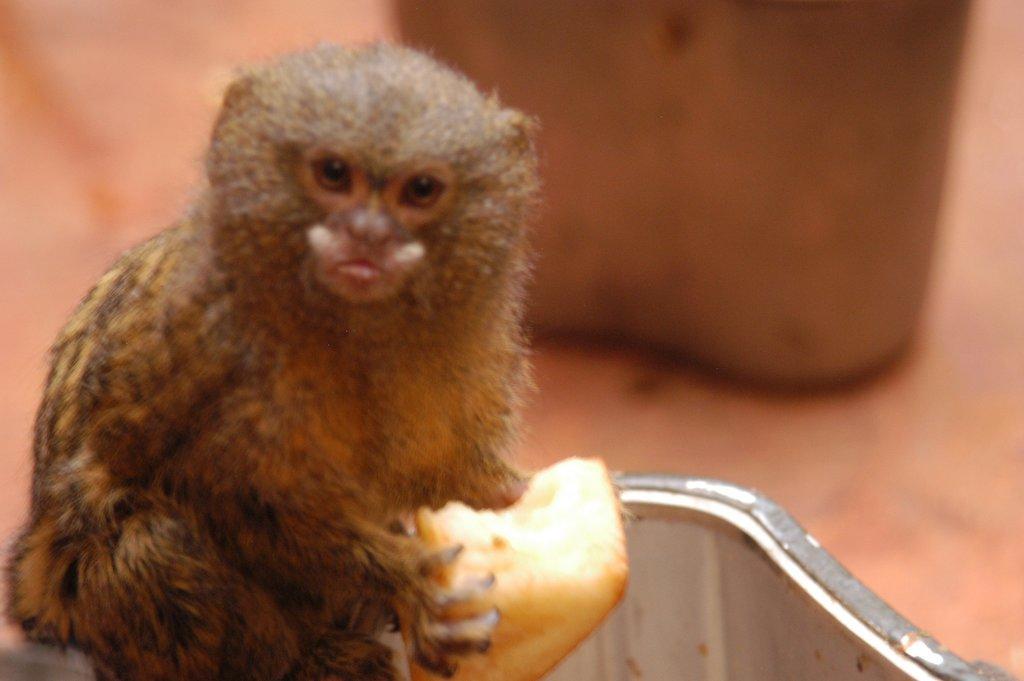In one or two sentences, can you explain what this image depicts? In this image we can see an animal holding something in the hand. In the background it is blur. 